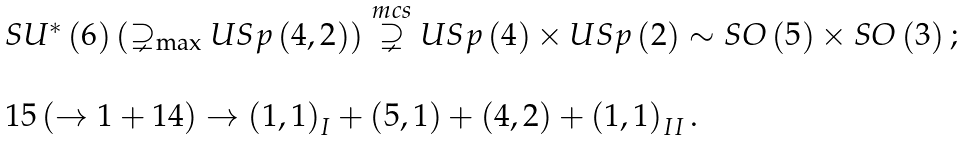Convert formula to latex. <formula><loc_0><loc_0><loc_500><loc_500>\begin{array} { l } S U ^ { \ast } \left ( 6 \right ) \left ( \supsetneq _ { \max } U S p \left ( 4 , 2 \right ) \right ) \overset { m c s } { \supsetneq } U S p \left ( 4 \right ) \times U S p \left ( 2 \right ) \sim S O \left ( 5 \right ) \times S O \left ( 3 \right ) ; \\ \\ 1 5 \left ( \rightarrow 1 + 1 4 \right ) \rightarrow \left ( 1 , 1 \right ) _ { I } + \left ( 5 , 1 \right ) + \left ( 4 , 2 \right ) + \left ( 1 , 1 \right ) _ { I I } . \end{array}</formula> 